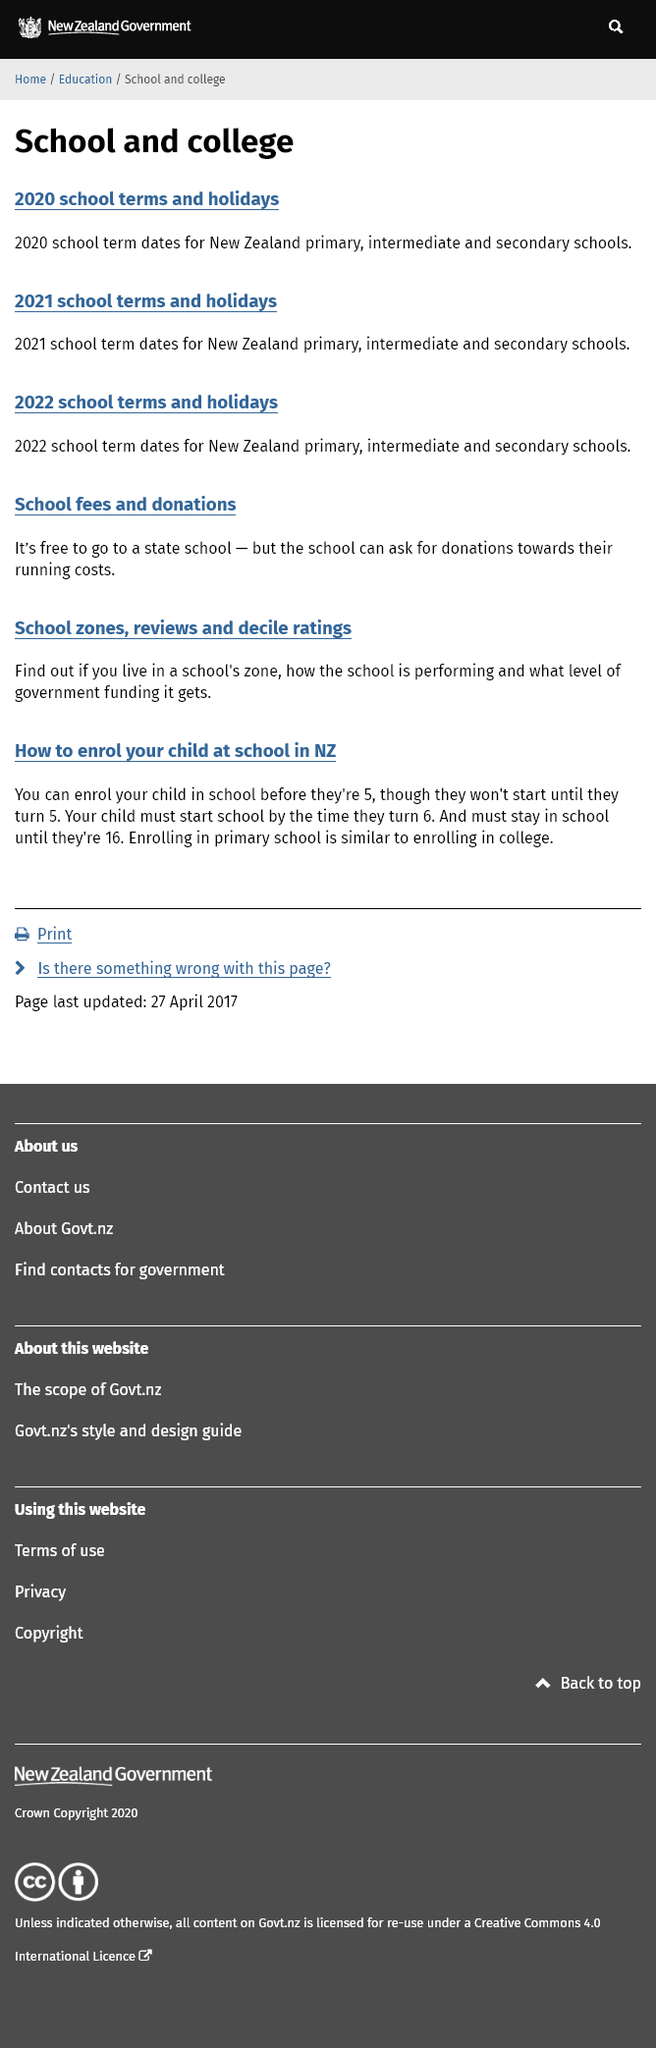Draw attention to some important aspects in this diagram. The website states that if one is unsure if they live in the correct school zone for a particular school, they can click on the "School zones" link to verify their address and ensure that they are in the correct zone. The fee for attending this school is waived, but donations are accepted to support the school's operation. It is mandatory for children to start school by the time they turn 6 years old, however, they can be enrolled in school before they reach the age of 5. 